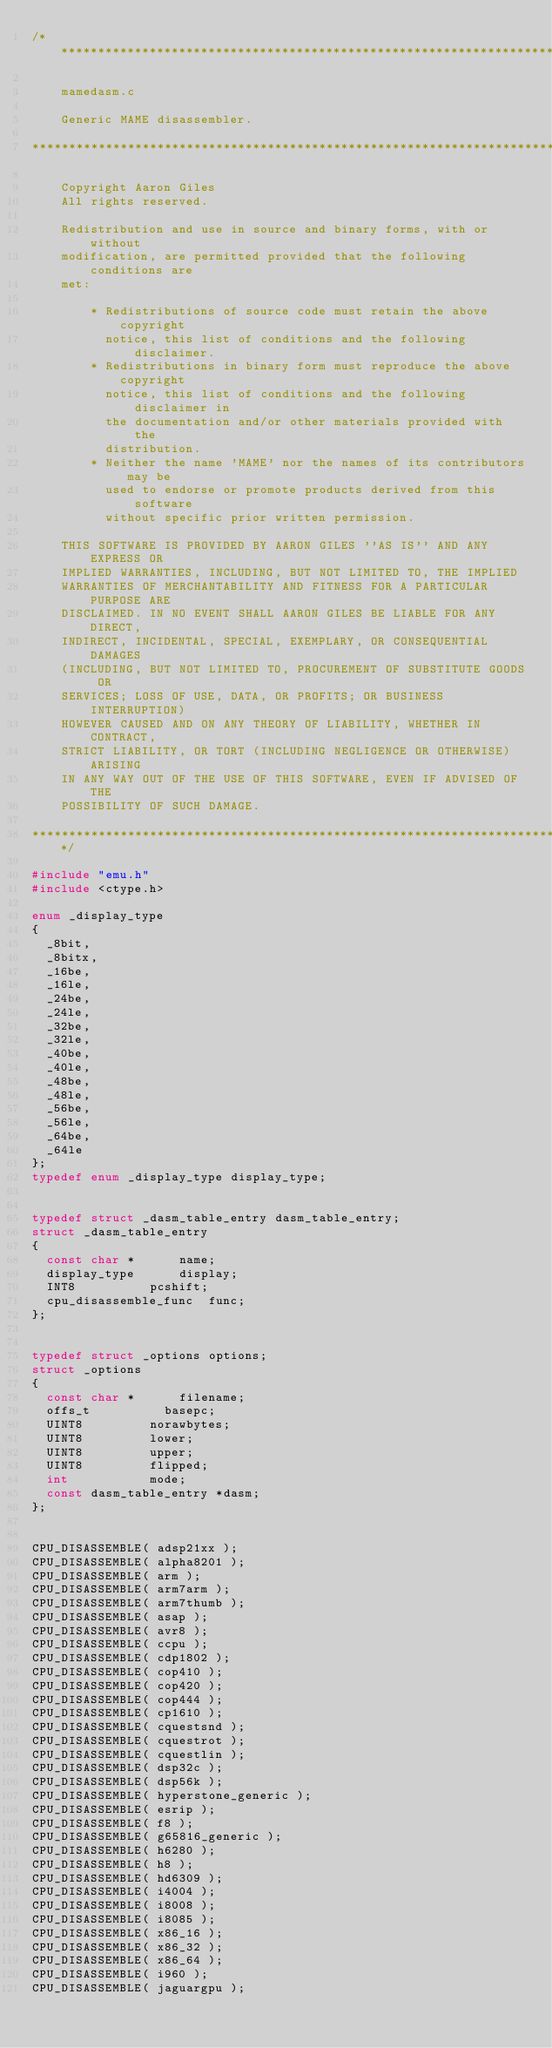<code> <loc_0><loc_0><loc_500><loc_500><_C_>/***************************************************************************

    mamedasm.c

    Generic MAME disassembler.

****************************************************************************

    Copyright Aaron Giles
    All rights reserved.

    Redistribution and use in source and binary forms, with or without
    modification, are permitted provided that the following conditions are
    met:

        * Redistributions of source code must retain the above copyright
          notice, this list of conditions and the following disclaimer.
        * Redistributions in binary form must reproduce the above copyright
          notice, this list of conditions and the following disclaimer in
          the documentation and/or other materials provided with the
          distribution.
        * Neither the name 'MAME' nor the names of its contributors may be
          used to endorse or promote products derived from this software
          without specific prior written permission.

    THIS SOFTWARE IS PROVIDED BY AARON GILES ''AS IS'' AND ANY EXPRESS OR
    IMPLIED WARRANTIES, INCLUDING, BUT NOT LIMITED TO, THE IMPLIED
    WARRANTIES OF MERCHANTABILITY AND FITNESS FOR A PARTICULAR PURPOSE ARE
    DISCLAIMED. IN NO EVENT SHALL AARON GILES BE LIABLE FOR ANY DIRECT,
    INDIRECT, INCIDENTAL, SPECIAL, EXEMPLARY, OR CONSEQUENTIAL DAMAGES
    (INCLUDING, BUT NOT LIMITED TO, PROCUREMENT OF SUBSTITUTE GOODS OR
    SERVICES; LOSS OF USE, DATA, OR PROFITS; OR BUSINESS INTERRUPTION)
    HOWEVER CAUSED AND ON ANY THEORY OF LIABILITY, WHETHER IN CONTRACT,
    STRICT LIABILITY, OR TORT (INCLUDING NEGLIGENCE OR OTHERWISE) ARISING
    IN ANY WAY OUT OF THE USE OF THIS SOFTWARE, EVEN IF ADVISED OF THE
    POSSIBILITY OF SUCH DAMAGE.

****************************************************************************/

#include "emu.h"
#include <ctype.h>

enum _display_type
{
	_8bit,
	_8bitx,
	_16be,
	_16le,
	_24be,
	_24le,
	_32be,
	_32le,
	_40be,
	_40le,
	_48be,
	_48le,
	_56be,
	_56le,
	_64be,
	_64le
};
typedef enum _display_type display_type;


typedef struct _dasm_table_entry dasm_table_entry;
struct _dasm_table_entry
{
	const char *			name;
	display_type			display;
	INT8					pcshift;
	cpu_disassemble_func	func;
};


typedef struct _options options;
struct _options
{
	const char *			filename;
	offs_t					basepc;
	UINT8					norawbytes;
	UINT8					lower;
	UINT8					upper;
	UINT8					flipped;
	int						mode;
	const dasm_table_entry *dasm;
};


CPU_DISASSEMBLE( adsp21xx );
CPU_DISASSEMBLE( alpha8201 );
CPU_DISASSEMBLE( arm );
CPU_DISASSEMBLE( arm7arm );
CPU_DISASSEMBLE( arm7thumb );
CPU_DISASSEMBLE( asap );
CPU_DISASSEMBLE( avr8 );
CPU_DISASSEMBLE( ccpu );
CPU_DISASSEMBLE( cdp1802 );
CPU_DISASSEMBLE( cop410 );
CPU_DISASSEMBLE( cop420 );
CPU_DISASSEMBLE( cop444 );
CPU_DISASSEMBLE( cp1610 );
CPU_DISASSEMBLE( cquestsnd );
CPU_DISASSEMBLE( cquestrot );
CPU_DISASSEMBLE( cquestlin );
CPU_DISASSEMBLE( dsp32c );
CPU_DISASSEMBLE( dsp56k );
CPU_DISASSEMBLE( hyperstone_generic );
CPU_DISASSEMBLE( esrip );
CPU_DISASSEMBLE( f8 );
CPU_DISASSEMBLE( g65816_generic );
CPU_DISASSEMBLE( h6280 );
CPU_DISASSEMBLE( h8 );
CPU_DISASSEMBLE( hd6309 );
CPU_DISASSEMBLE( i4004 );
CPU_DISASSEMBLE( i8008 );
CPU_DISASSEMBLE( i8085 );
CPU_DISASSEMBLE( x86_16 );
CPU_DISASSEMBLE( x86_32 );
CPU_DISASSEMBLE( x86_64 );
CPU_DISASSEMBLE( i960 );
CPU_DISASSEMBLE( jaguargpu );</code> 